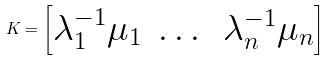Convert formula to latex. <formula><loc_0><loc_0><loc_500><loc_500>K = \begin{bmatrix} \lambda _ { 1 } ^ { - 1 } \mu _ { 1 } & \dots & \lambda _ { n } ^ { - 1 } \mu _ { n } \end{bmatrix}</formula> 